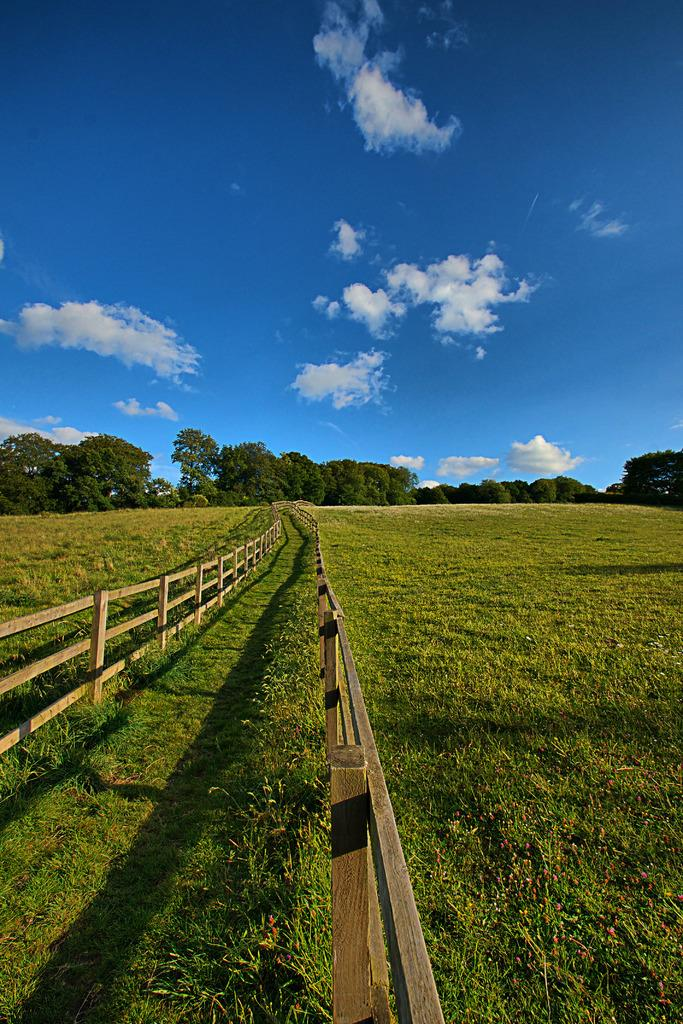What is located in the middle of the image? There is a fencing in the middle of the image. What type of terrain is visible in the image? There is grass in the image. What can be seen in the background of the image? There are trees at the back side of the image. What color is the sky in the image? The sky is blue in color and visible at the top of the image. What type of voice can be heard coming from the dad in the image? There is no dad or voice present in the image. Is there any water visible in the image? No, there is no water visible in the image. 